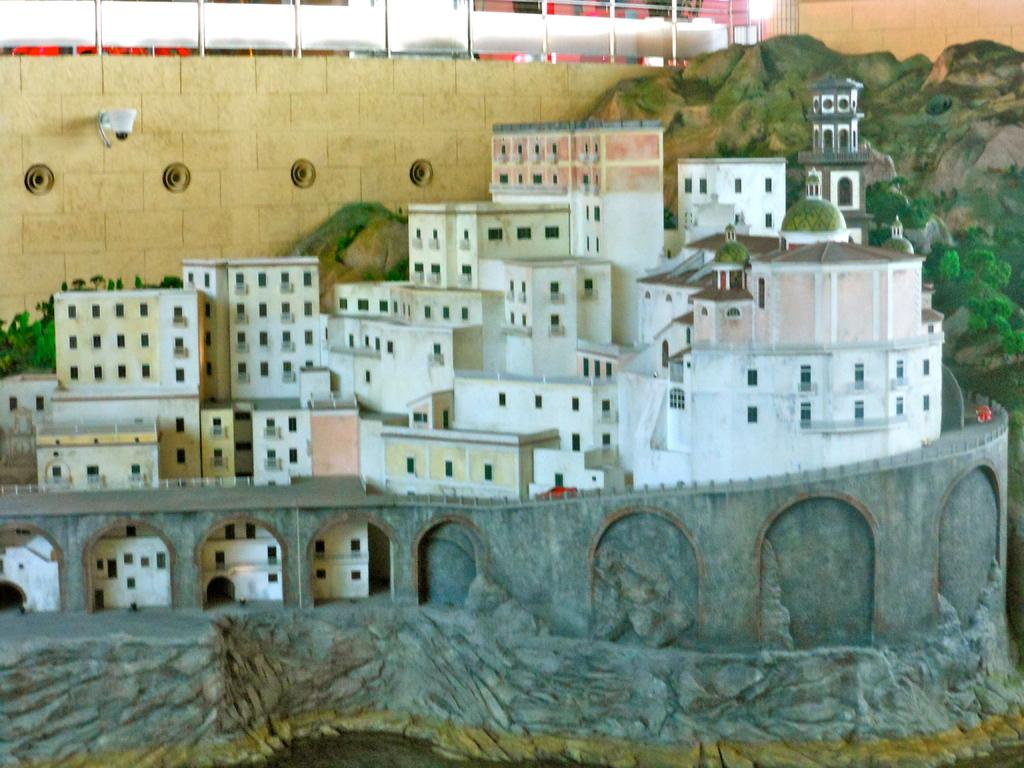What type of structures can be seen in the image? There are buildings in the image. What is the purpose of the barrier in the image? There is a fence in the image, which serves as a barrier or boundary. What type of natural elements are present in the image? There are trees and mountains in the image, as well as plants. Can you determine the time of day the image was taken? The image was likely taken during the day, as there is sufficient light to see the details clearly. What type of bulb is being used to illuminate the vegetable garden in the image? There is no vegetable garden or bulb present in the image. How many hammers can be seen in the image? There are no hammers present in the image. 